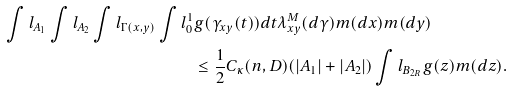Convert formula to latex. <formula><loc_0><loc_0><loc_500><loc_500>\int l _ { A _ { 1 } } \int l _ { A _ { 2 } } \int l _ { \Gamma ( x , y ) } \int l _ { 0 } ^ { 1 } & { g ( \gamma _ { x y } ( t ) ) } d t \lambda ^ { M } _ { x y } ( d \gamma ) m ( d x ) m ( d y ) \\ & \leq \frac { 1 } { 2 } C _ { \kappa } ( n , D ) ( | A _ { 1 } | + | A _ { 2 } | ) \int l _ { B _ { 2 R } } g ( z ) m ( d z ) .</formula> 